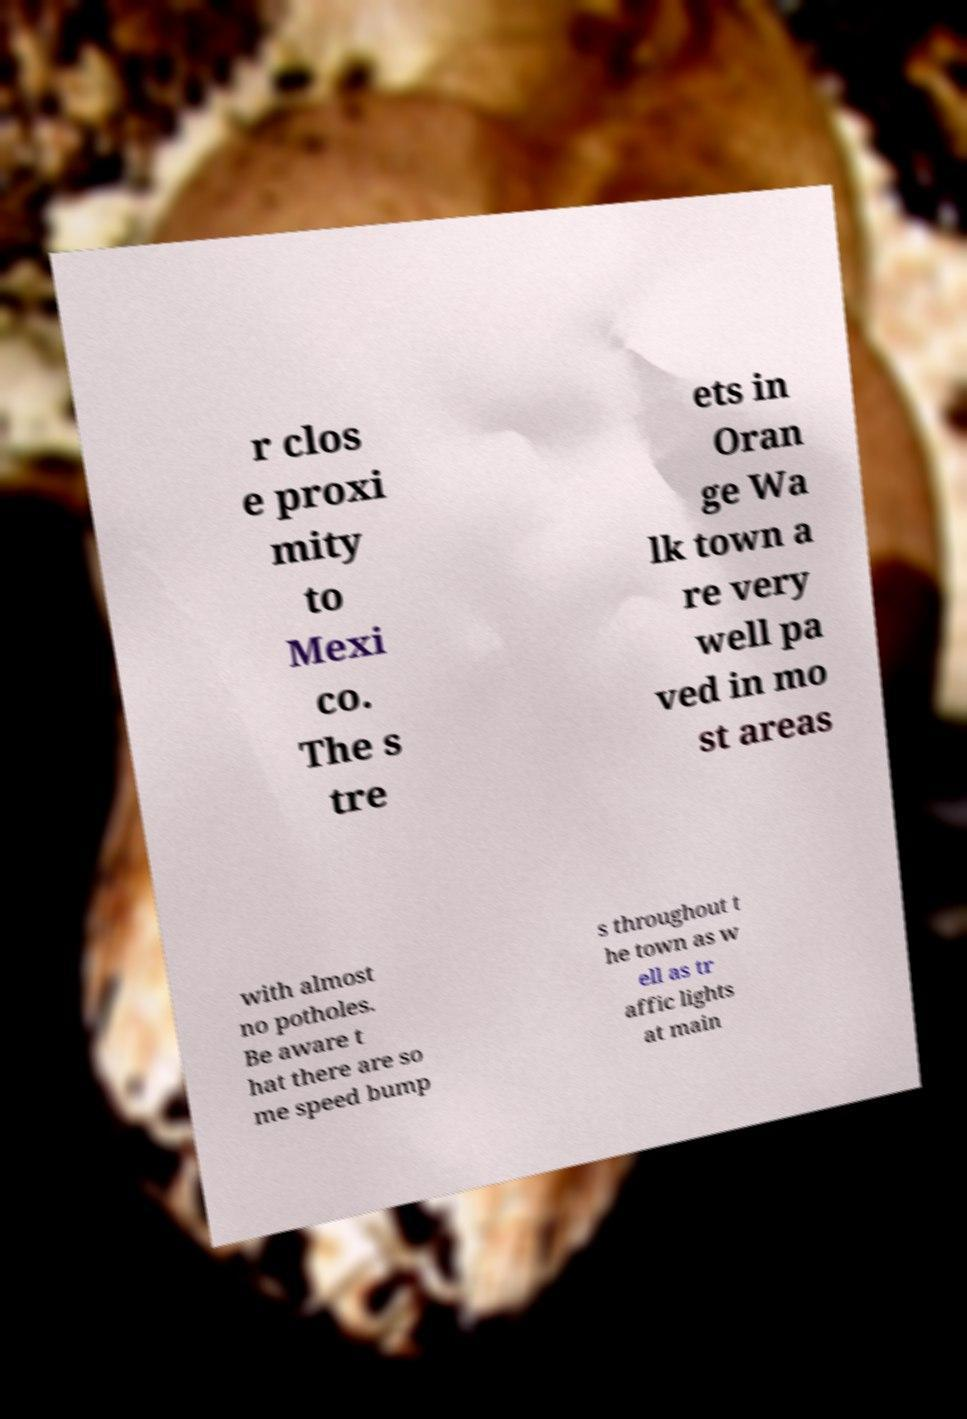I need the written content from this picture converted into text. Can you do that? r clos e proxi mity to Mexi co. The s tre ets in Oran ge Wa lk town a re very well pa ved in mo st areas with almost no potholes. Be aware t hat there are so me speed bump s throughout t he town as w ell as tr affic lights at main 